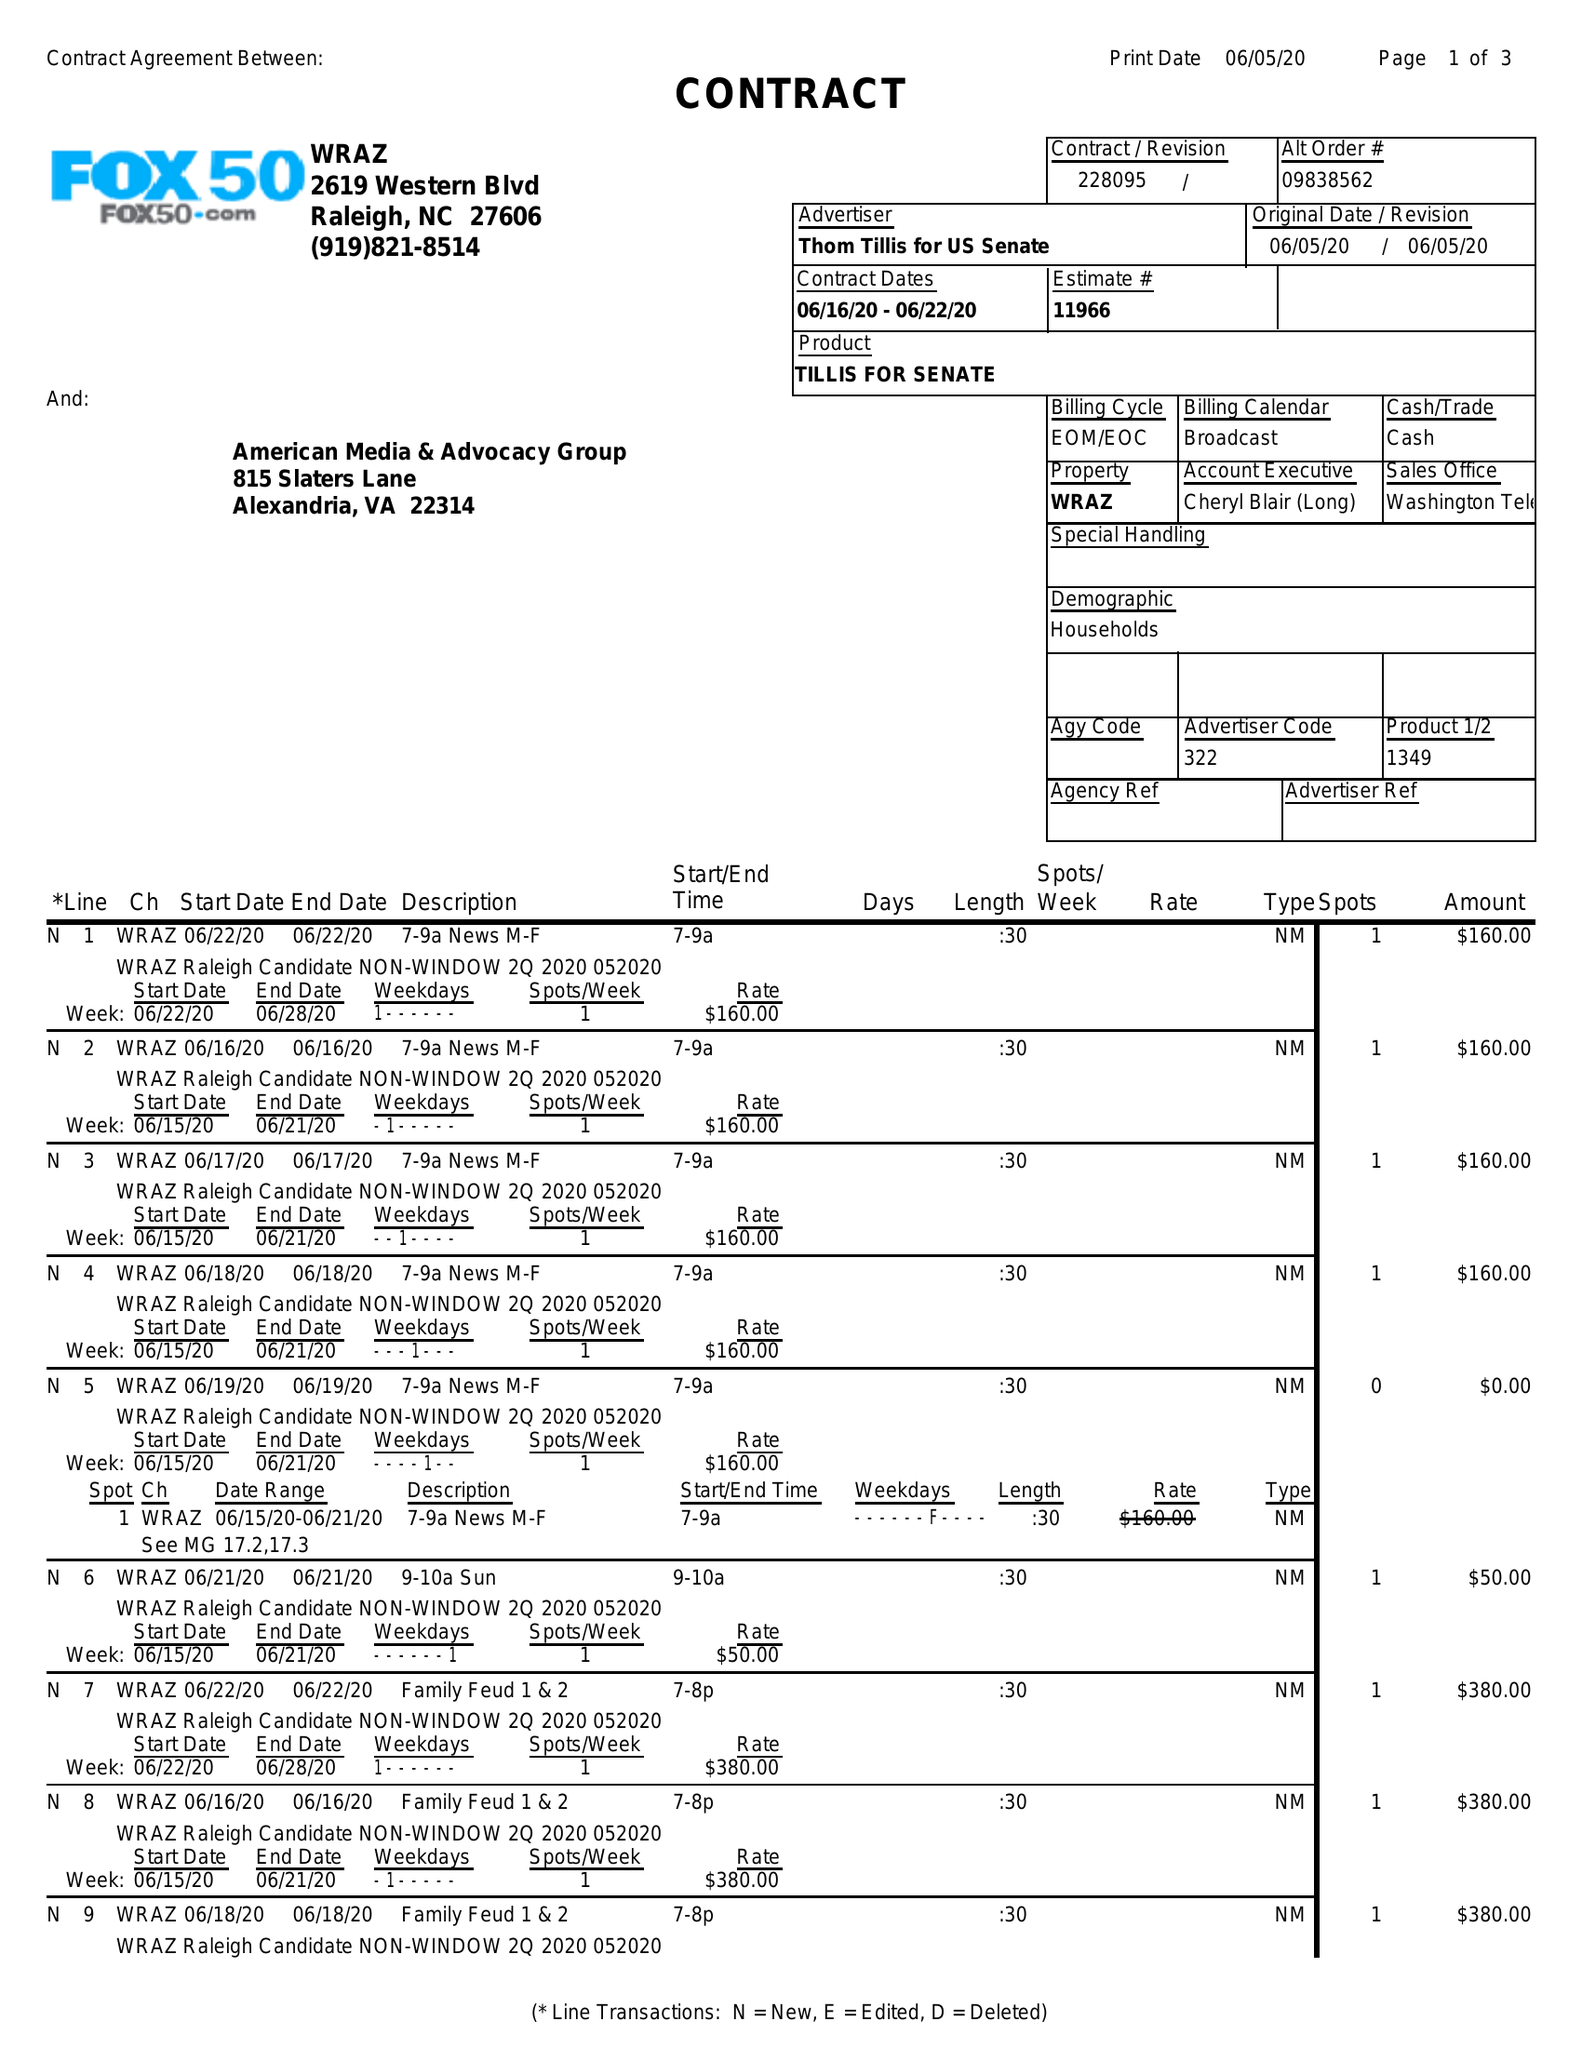What is the value for the flight_to?
Answer the question using a single word or phrase. 06/22/20 